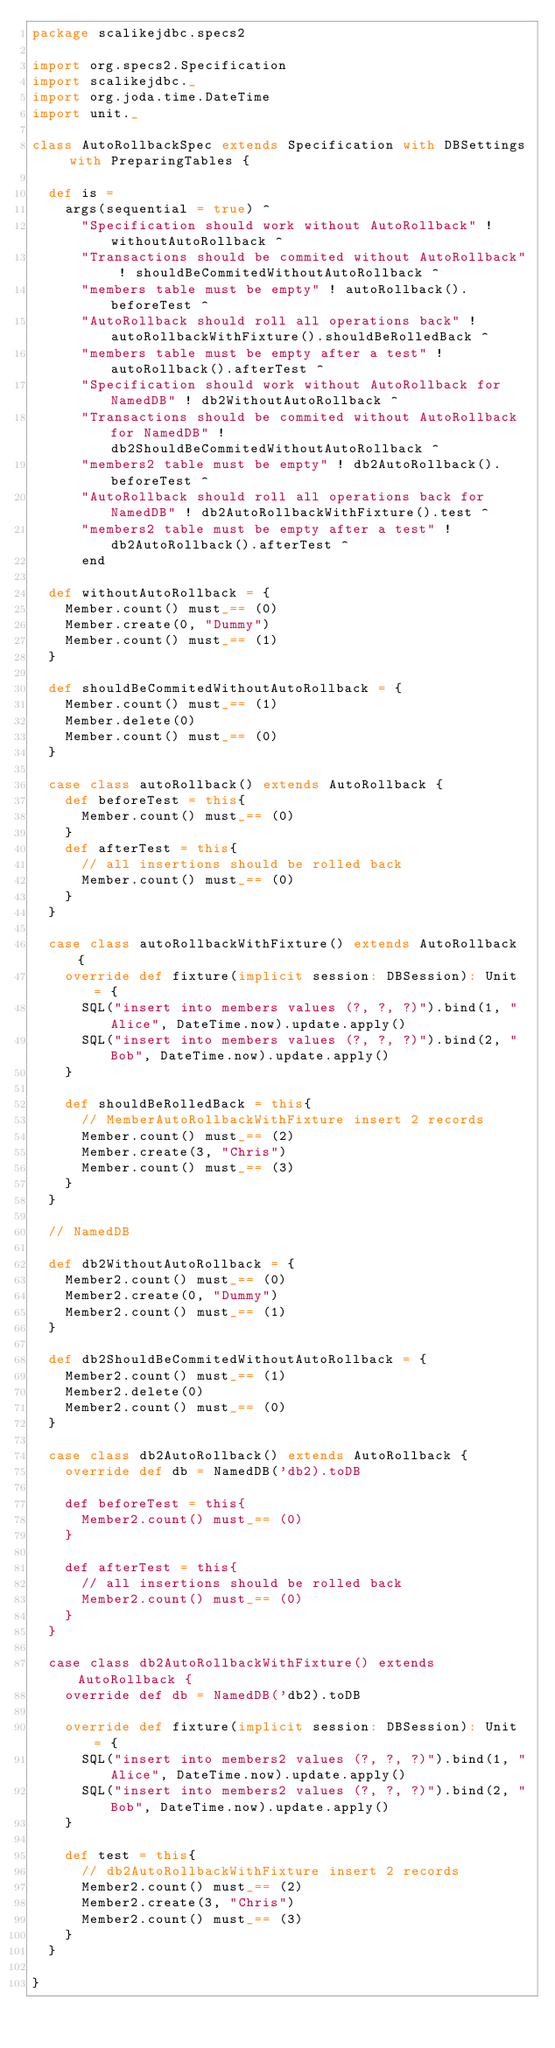Convert code to text. <code><loc_0><loc_0><loc_500><loc_500><_Scala_>package scalikejdbc.specs2

import org.specs2.Specification
import scalikejdbc._
import org.joda.time.DateTime
import unit._

class AutoRollbackSpec extends Specification with DBSettings with PreparingTables {

  def is =
    args(sequential = true) ^
      "Specification should work without AutoRollback" ! withoutAutoRollback ^
      "Transactions should be commited without AutoRollback" ! shouldBeCommitedWithoutAutoRollback ^
      "members table must be empty" ! autoRollback().beforeTest ^
      "AutoRollback should roll all operations back" ! autoRollbackWithFixture().shouldBeRolledBack ^
      "members table must be empty after a test" ! autoRollback().afterTest ^
      "Specification should work without AutoRollback for NamedDB" ! db2WithoutAutoRollback ^
      "Transactions should be commited without AutoRollback for NamedDB" ! db2ShouldBeCommitedWithoutAutoRollback ^
      "members2 table must be empty" ! db2AutoRollback().beforeTest ^
      "AutoRollback should roll all operations back for NamedDB" ! db2AutoRollbackWithFixture().test ^
      "members2 table must be empty after a test" ! db2AutoRollback().afterTest ^
      end

  def withoutAutoRollback = {
    Member.count() must_== (0)
    Member.create(0, "Dummy")
    Member.count() must_== (1)
  }

  def shouldBeCommitedWithoutAutoRollback = {
    Member.count() must_== (1)
    Member.delete(0)
    Member.count() must_== (0)
  }

  case class autoRollback() extends AutoRollback {
    def beforeTest = this{
      Member.count() must_== (0)
    }
    def afterTest = this{
      // all insertions should be rolled back
      Member.count() must_== (0)
    }
  }

  case class autoRollbackWithFixture() extends AutoRollback {
    override def fixture(implicit session: DBSession): Unit = {
      SQL("insert into members values (?, ?, ?)").bind(1, "Alice", DateTime.now).update.apply()
      SQL("insert into members values (?, ?, ?)").bind(2, "Bob", DateTime.now).update.apply()
    }

    def shouldBeRolledBack = this{
      // MemberAutoRollbackWithFixture insert 2 records
      Member.count() must_== (2)
      Member.create(3, "Chris")
      Member.count() must_== (3)
    }
  }

  // NamedDB

  def db2WithoutAutoRollback = {
    Member2.count() must_== (0)
    Member2.create(0, "Dummy")
    Member2.count() must_== (1)
  }

  def db2ShouldBeCommitedWithoutAutoRollback = {
    Member2.count() must_== (1)
    Member2.delete(0)
    Member2.count() must_== (0)
  }

  case class db2AutoRollback() extends AutoRollback {
    override def db = NamedDB('db2).toDB

    def beforeTest = this{
      Member2.count() must_== (0)
    }

    def afterTest = this{
      // all insertions should be rolled back
      Member2.count() must_== (0)
    }
  }

  case class db2AutoRollbackWithFixture() extends AutoRollback {
    override def db = NamedDB('db2).toDB

    override def fixture(implicit session: DBSession): Unit = {
      SQL("insert into members2 values (?, ?, ?)").bind(1, "Alice", DateTime.now).update.apply()
      SQL("insert into members2 values (?, ?, ?)").bind(2, "Bob", DateTime.now).update.apply()
    }

    def test = this{
      // db2AutoRollbackWithFixture insert 2 records
      Member2.count() must_== (2)
      Member2.create(3, "Chris")
      Member2.count() must_== (3)
    }
  }

}

</code> 